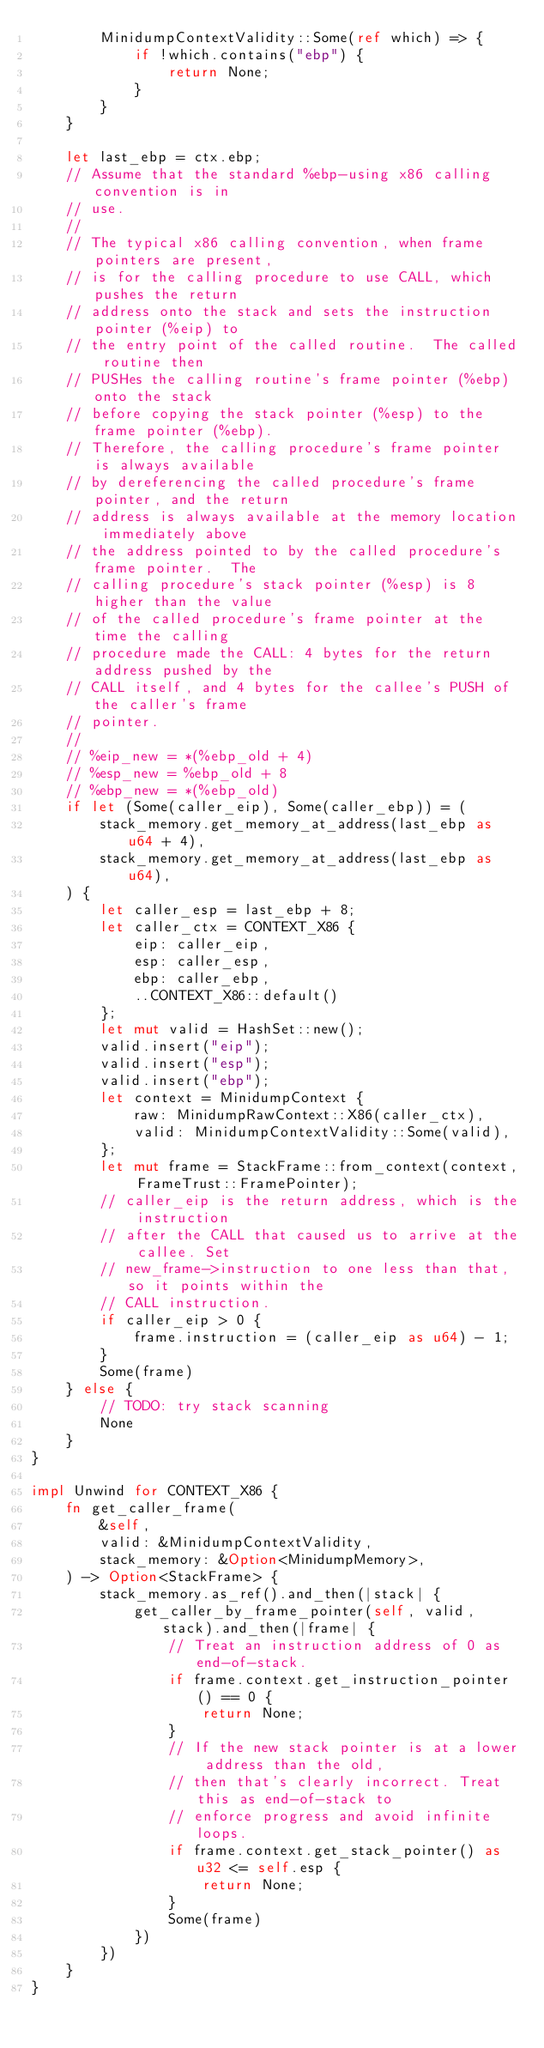Convert code to text. <code><loc_0><loc_0><loc_500><loc_500><_Rust_>        MinidumpContextValidity::Some(ref which) => {
            if !which.contains("ebp") {
                return None;
            }
        }
    }

    let last_ebp = ctx.ebp;
    // Assume that the standard %ebp-using x86 calling convention is in
    // use.
    //
    // The typical x86 calling convention, when frame pointers are present,
    // is for the calling procedure to use CALL, which pushes the return
    // address onto the stack and sets the instruction pointer (%eip) to
    // the entry point of the called routine.  The called routine then
    // PUSHes the calling routine's frame pointer (%ebp) onto the stack
    // before copying the stack pointer (%esp) to the frame pointer (%ebp).
    // Therefore, the calling procedure's frame pointer is always available
    // by dereferencing the called procedure's frame pointer, and the return
    // address is always available at the memory location immediately above
    // the address pointed to by the called procedure's frame pointer.  The
    // calling procedure's stack pointer (%esp) is 8 higher than the value
    // of the called procedure's frame pointer at the time the calling
    // procedure made the CALL: 4 bytes for the return address pushed by the
    // CALL itself, and 4 bytes for the callee's PUSH of the caller's frame
    // pointer.
    //
    // %eip_new = *(%ebp_old + 4)
    // %esp_new = %ebp_old + 8
    // %ebp_new = *(%ebp_old)
    if let (Some(caller_eip), Some(caller_ebp)) = (
        stack_memory.get_memory_at_address(last_ebp as u64 + 4),
        stack_memory.get_memory_at_address(last_ebp as u64),
    ) {
        let caller_esp = last_ebp + 8;
        let caller_ctx = CONTEXT_X86 {
            eip: caller_eip,
            esp: caller_esp,
            ebp: caller_ebp,
            ..CONTEXT_X86::default()
        };
        let mut valid = HashSet::new();
        valid.insert("eip");
        valid.insert("esp");
        valid.insert("ebp");
        let context = MinidumpContext {
            raw: MinidumpRawContext::X86(caller_ctx),
            valid: MinidumpContextValidity::Some(valid),
        };
        let mut frame = StackFrame::from_context(context, FrameTrust::FramePointer);
        // caller_eip is the return address, which is the instruction
        // after the CALL that caused us to arrive at the callee. Set
        // new_frame->instruction to one less than that, so it points within the
        // CALL instruction.
        if caller_eip > 0 {
            frame.instruction = (caller_eip as u64) - 1;
        }
        Some(frame)
    } else {
        // TODO: try stack scanning
        None
    }
}

impl Unwind for CONTEXT_X86 {
    fn get_caller_frame(
        &self,
        valid: &MinidumpContextValidity,
        stack_memory: &Option<MinidumpMemory>,
    ) -> Option<StackFrame> {
        stack_memory.as_ref().and_then(|stack| {
            get_caller_by_frame_pointer(self, valid, stack).and_then(|frame| {
                // Treat an instruction address of 0 as end-of-stack.
                if frame.context.get_instruction_pointer() == 0 {
                    return None;
                }
                // If the new stack pointer is at a lower address than the old,
                // then that's clearly incorrect. Treat this as end-of-stack to
                // enforce progress and avoid infinite loops.
                if frame.context.get_stack_pointer() as u32 <= self.esp {
                    return None;
                }
                Some(frame)
            })
        })
    }
}
</code> 